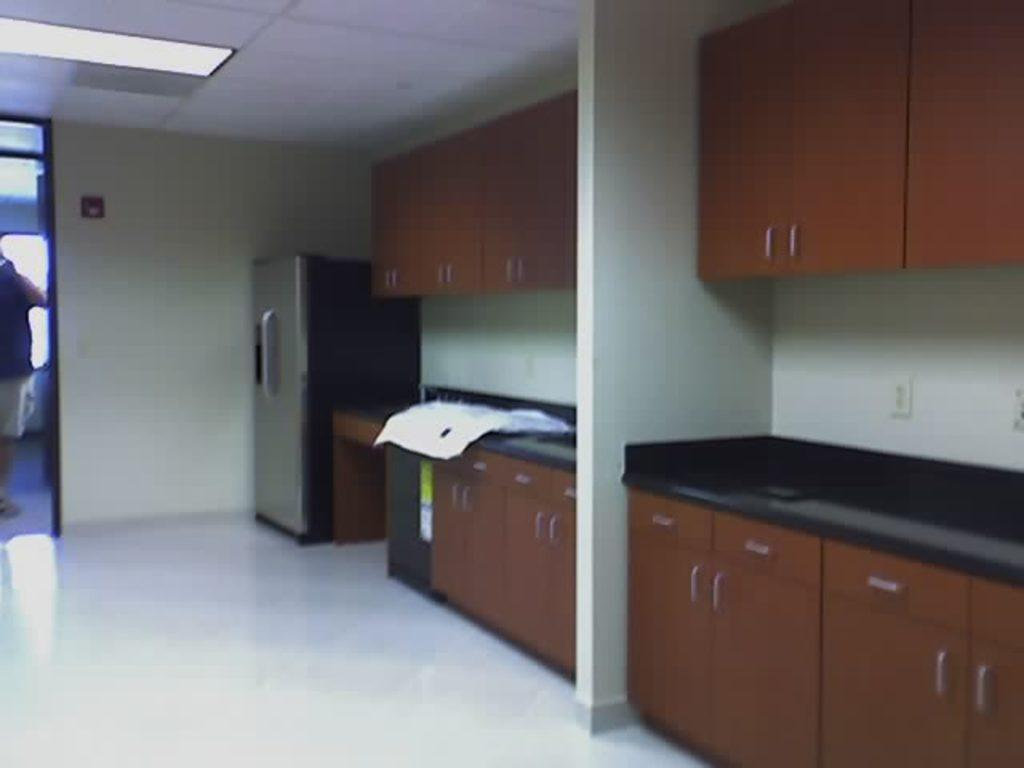What type of furniture is present in the image? There are cupboards in the image. What appliance can be seen in the image? There is a refrigerator in the image. What source of illumination is visible in the image? There is a light in the image. What part of the room is visible in the image? There is a ceiling in the image. What surface is the person standing on in the image? The person is standing on the floor in the image. What is causing the person to feel hot in the image? There is no indication in the image that the person is feeling hot, and no cause for this can be determined. 